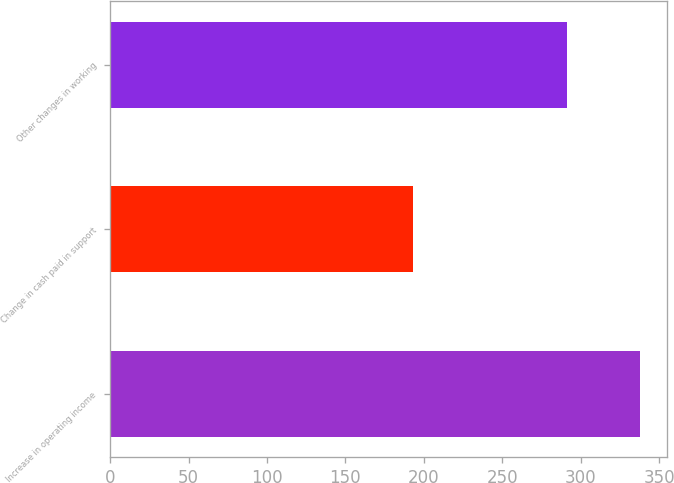<chart> <loc_0><loc_0><loc_500><loc_500><bar_chart><fcel>Increase in operating income<fcel>Change in cash paid in support<fcel>Other changes in working<nl><fcel>338<fcel>193<fcel>291<nl></chart> 